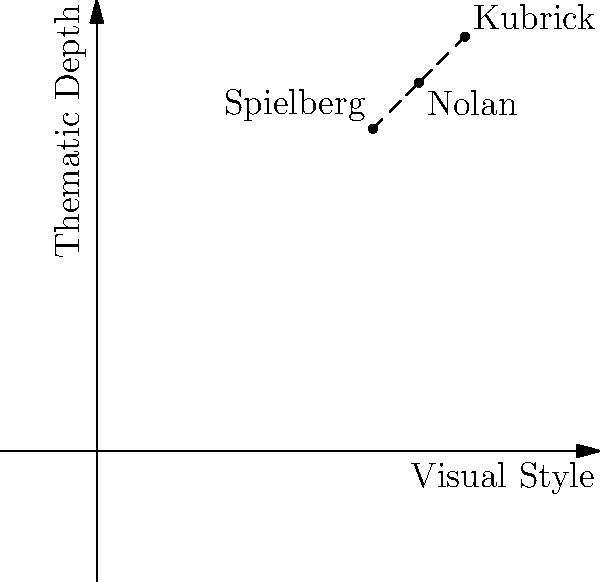Based on the graph comparing the visual styles and thematic depth of three renowned directors addressing similar themes, which director's approach might be most effective in provoking important discussions through film, and why? 1. Analyze the graph:
   - The x-axis represents "Visual Style"
   - The y-axis represents "Thematic Depth"
   - Three directors are plotted: Kubrick, Spielberg, and Nolan

2. Compare the positions:
   - Kubrick: Highest on both axes (0.8, 0.9)
   - Nolan: Middle position (0.7, 0.8)
   - Spielberg: Lowest on both axes (0.6, 0.7)

3. Interpret the data:
   - Higher values indicate stronger visual style and deeper thematic exploration
   - Kubrick's position suggests he excels in both areas

4. Consider the question's context:
   - The goal is to provoke important discussions through film
   - Both visual style and thematic depth contribute to this goal

5. Evaluate effectiveness:
   - Kubrick's high scores in both areas suggest his approach would be most effective
   - His strong visual style can engage viewers
   - His deep thematic exploration can stimulate thought and discussion

6. Reflect on the persona:
   - As a supportive sibling who admires courage in provoking discussions, Kubrick's approach aligns well with this perspective
Answer: Kubrick, due to his superior combination of visual style and thematic depth. 